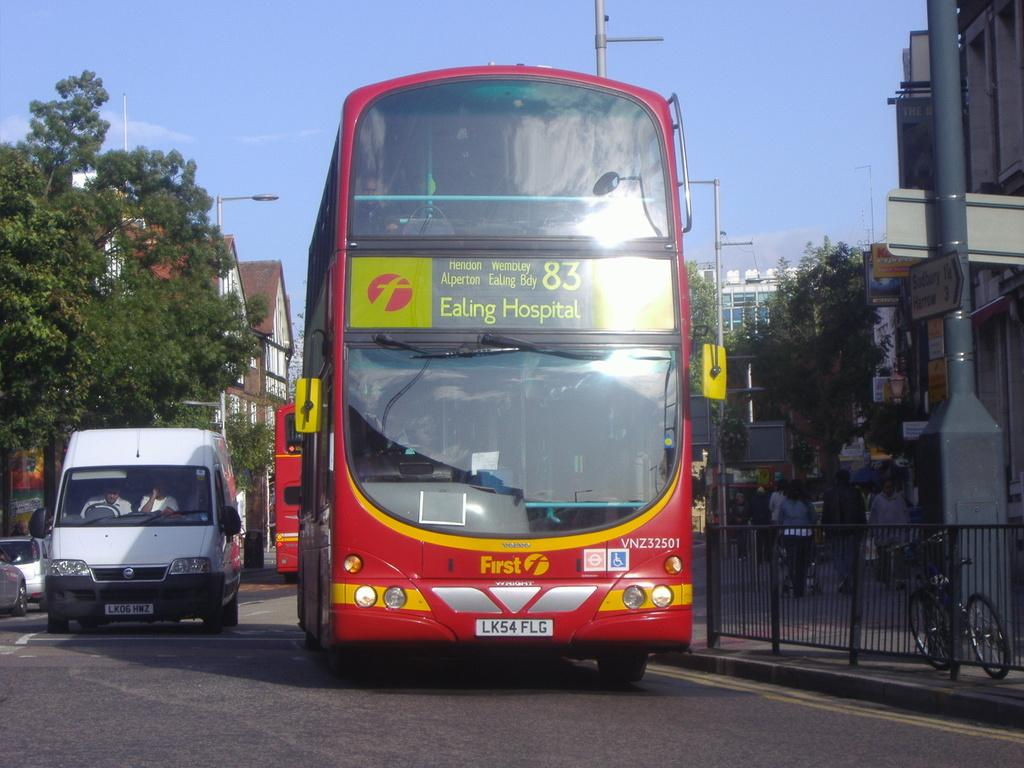<image>
Give a short and clear explanation of the subsequent image. A double decker bus heading to Ealing Hospital rides down the street. 